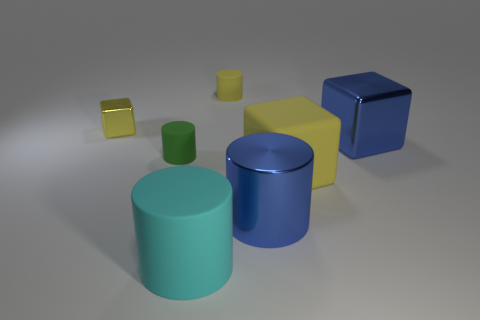Add 2 big yellow things. How many objects exist? 9 Subtract all cubes. How many objects are left? 4 Subtract 0 blue balls. How many objects are left? 7 Subtract all gray metallic cylinders. Subtract all large yellow rubber blocks. How many objects are left? 6 Add 2 big cyan objects. How many big cyan objects are left? 3 Add 4 yellow rubber cylinders. How many yellow rubber cylinders exist? 5 